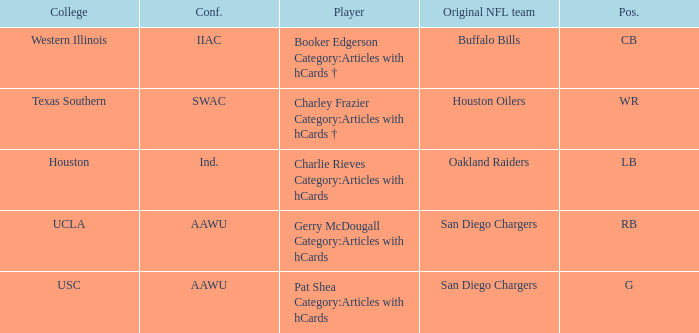What player's original team are the Oakland Raiders? Charlie Rieves Category:Articles with hCards. 